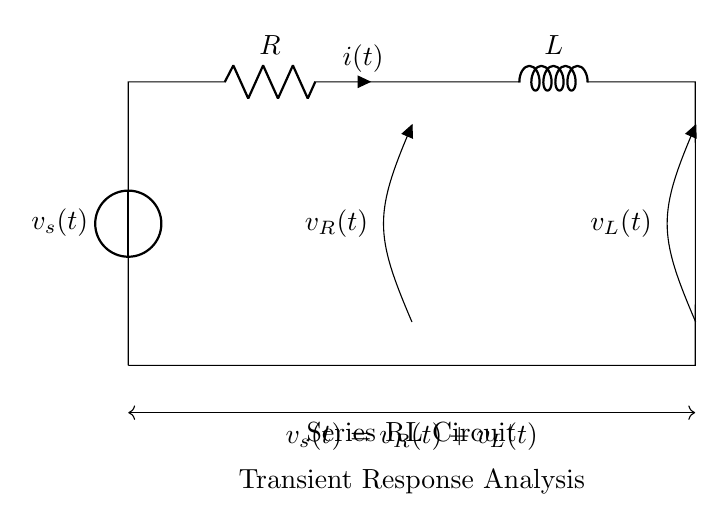What is the voltage source in this circuit? The voltage source is labeled as \( v_s(t) \) in the circuit diagram, indicating the input voltage applied to the series RL circuit.
Answer: v_s(t) What components are present in this circuit? The circuit contains two main components: a resistor denoted as \( R \) and an inductor denoted as \( L \). These elements are essential for establishing the series RL configuration.
Answer: Resistor and inductor What is the equation representing the total voltage in the circuit? The equation shown at the bottom of the circuit states that the total voltage \( v_s(t) \) is equal to the sum of the voltages across the resistor \( v_R(t) \) and the inductor \( v_L(t) \). This relationship is a fundamental aspect of Kirchhoff's voltage law.
Answer: v_s(t) = v_R(t) + v_L(t) How many loops are present in this circuit? The circuit forms a single loop as it connects the voltage source in series with the resistor and inductor, creating a closed path for current flow.
Answer: One What is the nature of the transient response in an RL circuit? In a series RL circuit, the transient response involves how the current \( i(t) \) changes over time when the circuit is energized. Initially, the current rises slowly due to the inductor's opposition to changes in current, ultimately reaching a steady state determined by the voltage and resistance. This dynamic behavior is crucial in power system analysis.
Answer: Time-varying current response What is the relationship between the voltages in terms of their time-varying nature? The voltages across the resistor \( v_R(t) \) and inductor \( v_L(t) \) vary as a function of time and are dependent on the instantaneous current \( i(t) \) through the components. Specifically, the voltage across the resistor is proportional to the current, while the voltage across the inductor depends on the rate of change of current. This relationship captures the essence of the RL circuit's transient response.
Answer: Voltage depends on current and its rate of change What happens to the current in an RL circuit after a sudden change in voltage? When the voltage source \( v_s(t) \) is suddenly applied, the current \( i(t) \) does not immediately jump to its final value but rather increases gradually due to the inductor opposing sudden changes in current. This results in an exponential growth towards the steady-state value over time, characterized by the time constant which is related to the values of \( R \) and \( L \).
Answer: Gradual increase to steady state 